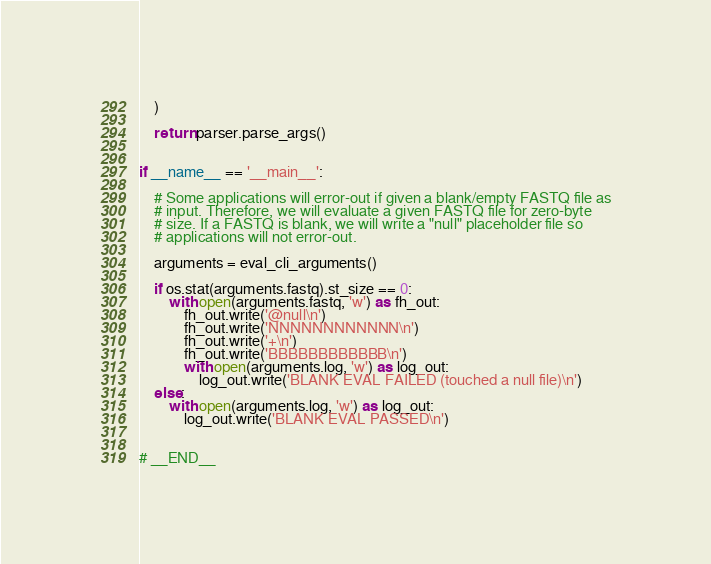Convert code to text. <code><loc_0><loc_0><loc_500><loc_500><_Python_>    )

    return parser.parse_args()


if __name__ == '__main__':

    # Some applications will error-out if given a blank/empty FASTQ file as
    # input. Therefore, we will evaluate a given FASTQ file for zero-byte
    # size. If a FASTQ is blank, we will write a "null" placeholder file so
    # applications will not error-out.

    arguments = eval_cli_arguments()

    if os.stat(arguments.fastq).st_size == 0:
        with open(arguments.fastq, 'w') as fh_out:
            fh_out.write('@null\n')
            fh_out.write('NNNNNNNNNNNN\n')
            fh_out.write('+\n')
            fh_out.write('BBBBBBBBBBBB\n')
            with open(arguments.log, 'w') as log_out:
                log_out.write('BLANK EVAL FAILED (touched a null file)\n')
    else:
        with open(arguments.log, 'w') as log_out:
            log_out.write('BLANK EVAL PASSED\n')


# __END__
</code> 